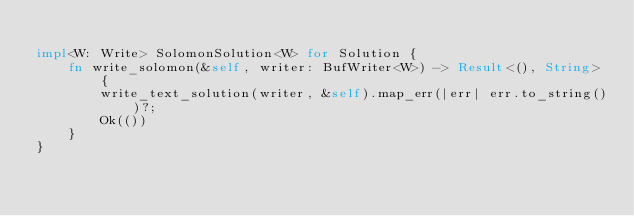<code> <loc_0><loc_0><loc_500><loc_500><_Rust_>
impl<W: Write> SolomonSolution<W> for Solution {
    fn write_solomon(&self, writer: BufWriter<W>) -> Result<(), String> {
        write_text_solution(writer, &self).map_err(|err| err.to_string())?;
        Ok(())
    }
}
</code> 